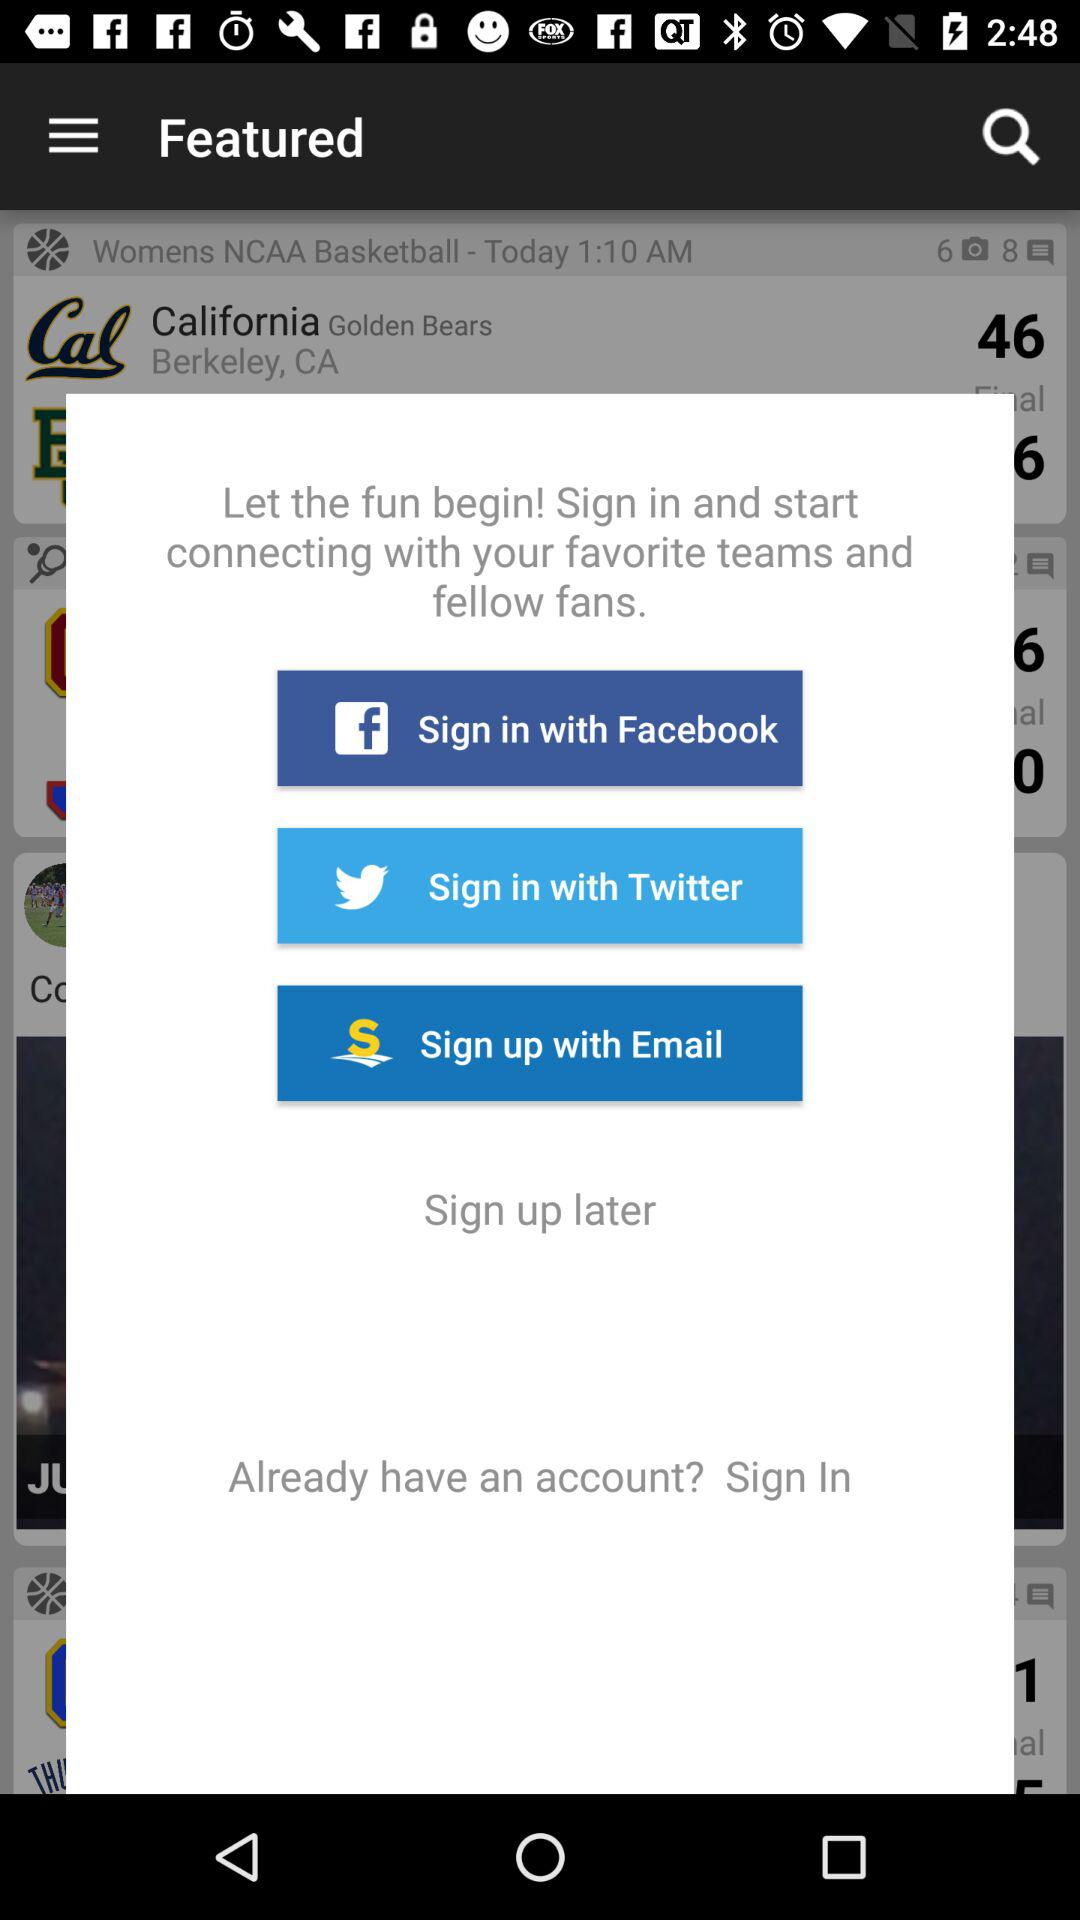Which applications can be used to sign in? The applications that can be used to sign in are "Facebook" and "Twitter". 